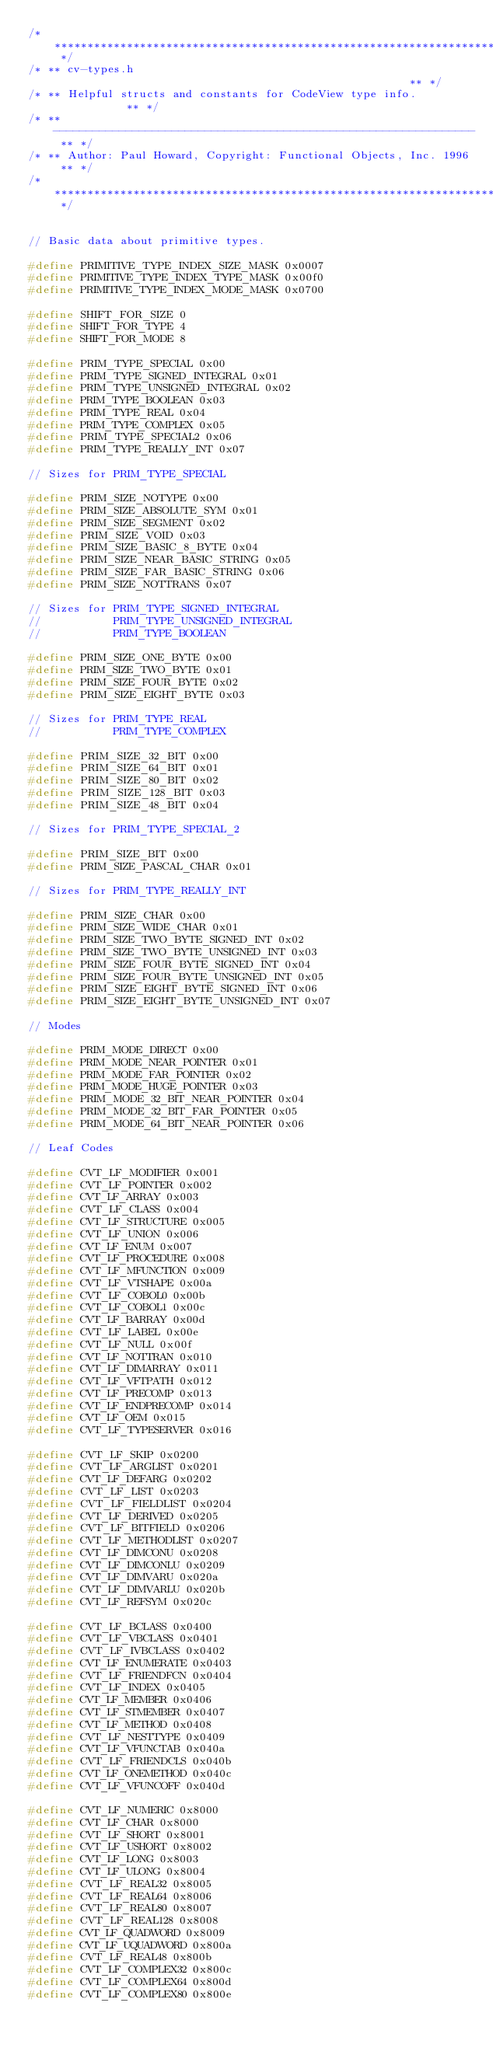Convert code to text. <code><loc_0><loc_0><loc_500><loc_500><_C_>/* ********************************************************************** */
/* ** cv-types.h                                                       ** */
/* ** Helpful structs and constants for CodeView type info.            ** */
/* ** ---------------------------------------------------------------- ** */
/* ** Author: Paul Howard, Copyright: Functional Objects, Inc. 1996 ** */
/* ********************************************************************** */


// Basic data about primitive types.

#define PRIMITIVE_TYPE_INDEX_SIZE_MASK 0x0007
#define PRIMITIVE_TYPE_INDEX_TYPE_MASK 0x00f0
#define PRIMITIVE_TYPE_INDEX_MODE_MASK 0x0700

#define SHIFT_FOR_SIZE 0
#define SHIFT_FOR_TYPE 4
#define SHIFT_FOR_MODE 8

#define PRIM_TYPE_SPECIAL 0x00
#define PRIM_TYPE_SIGNED_INTEGRAL 0x01
#define PRIM_TYPE_UNSIGNED_INTEGRAL 0x02
#define PRIM_TYPE_BOOLEAN 0x03
#define PRIM_TYPE_REAL 0x04
#define PRIM_TYPE_COMPLEX 0x05
#define PRIM_TYPE_SPECIAL2 0x06
#define PRIM_TYPE_REALLY_INT 0x07

// Sizes for PRIM_TYPE_SPECIAL

#define PRIM_SIZE_NOTYPE 0x00
#define PRIM_SIZE_ABSOLUTE_SYM 0x01
#define PRIM_SIZE_SEGMENT 0x02
#define PRIM_SIZE_VOID 0x03
#define PRIM_SIZE_BASIC_8_BYTE 0x04
#define PRIM_SIZE_NEAR_BASIC_STRING 0x05
#define PRIM_SIZE_FAR_BASIC_STRING 0x06
#define PRIM_SIZE_NOTTRANS 0x07

// Sizes for PRIM_TYPE_SIGNED_INTEGRAL
//           PRIM_TYPE_UNSIGNED_INTEGRAL
//           PRIM_TYPE_BOOLEAN

#define PRIM_SIZE_ONE_BYTE 0x00
#define PRIM_SIZE_TWO_BYTE 0x01
#define PRIM_SIZE_FOUR_BYTE 0x02
#define PRIM_SIZE_EIGHT_BYTE 0x03

// Sizes for PRIM_TYPE_REAL
//           PRIM_TYPE_COMPLEX

#define PRIM_SIZE_32_BIT 0x00
#define PRIM_SIZE_64_BIT 0x01
#define PRIM_SIZE_80_BIT 0x02
#define PRIM_SIZE_128_BIT 0x03
#define PRIM_SIZE_48_BIT 0x04

// Sizes for PRIM_TYPE_SPECIAL_2

#define PRIM_SIZE_BIT 0x00
#define PRIM_SIZE_PASCAL_CHAR 0x01

// Sizes for PRIM_TYPE_REALLY_INT

#define PRIM_SIZE_CHAR 0x00
#define PRIM_SIZE_WIDE_CHAR 0x01
#define PRIM_SIZE_TWO_BYTE_SIGNED_INT 0x02
#define PRIM_SIZE_TWO_BYTE_UNSIGNED_INT 0x03
#define PRIM_SIZE_FOUR_BYTE_SIGNED_INT 0x04
#define PRIM_SIZE_FOUR_BYTE_UNSIGNED_INT 0x05
#define PRIM_SIZE_EIGHT_BYTE_SIGNED_INT 0x06
#define PRIM_SIZE_EIGHT_BYTE_UNSIGNED_INT 0x07

// Modes

#define PRIM_MODE_DIRECT 0x00
#define PRIM_MODE_NEAR_POINTER 0x01
#define PRIM_MODE_FAR_POINTER 0x02
#define PRIM_MODE_HUGE_POINTER 0x03
#define PRIM_MODE_32_BIT_NEAR_POINTER 0x04
#define PRIM_MODE_32_BIT_FAR_POINTER 0x05
#define PRIM_MODE_64_BIT_NEAR_POINTER 0x06

// Leaf Codes

#define CVT_LF_MODIFIER 0x001
#define CVT_LF_POINTER 0x002
#define CVT_LF_ARRAY 0x003
#define CVT_LF_CLASS 0x004
#define CVT_LF_STRUCTURE 0x005
#define CVT_LF_UNION 0x006
#define CVT_LF_ENUM 0x007
#define CVT_LF_PROCEDURE 0x008
#define CVT_LF_MFUNCTION 0x009
#define CVT_LF_VTSHAPE 0x00a
#define CVT_LF_COBOL0 0x00b
#define CVT_LF_COBOL1 0x00c
#define CVT_LF_BARRAY 0x00d
#define CVT_LF_LABEL 0x00e
#define CVT_LF_NULL 0x00f
#define CVT_LF_NOTTRAN 0x010
#define CVT_LF_DIMARRAY 0x011
#define CVT_LF_VFTPATH 0x012
#define CVT_LF_PRECOMP 0x013
#define CVT_LF_ENDPRECOMP 0x014
#define CVT_LF_OEM 0x015
#define CVT_LF_TYPESERVER 0x016

#define CVT_LF_SKIP 0x0200
#define CVT_LF_ARGLIST 0x0201
#define CVT_LF_DEFARG 0x0202
#define CVT_LF_LIST 0x0203
#define CVT_LF_FIELDLIST 0x0204
#define CVT_LF_DERIVED 0x0205
#define CVT_LF_BITFIELD 0x0206
#define CVT_LF_METHODLIST 0x0207
#define CVT_LF_DIMCONU 0x0208
#define CVT_LF_DIMCONLU 0x0209
#define CVT_LF_DIMVARU 0x020a
#define CVT_LF_DIMVARLU 0x020b
#define CVT_LF_REFSYM 0x020c

#define CVT_LF_BCLASS 0x0400
#define CVT_LF_VBCLASS 0x0401
#define CVT_LF_IVBCLASS 0x0402
#define CVT_LF_ENUMERATE 0x0403
#define CVT_LF_FRIENDFCN 0x0404
#define CVT_LF_INDEX 0x0405
#define CVT_LF_MEMBER 0x0406
#define CVT_LF_STMEMBER 0x0407
#define CVT_LF_METHOD 0x0408
#define CVT_LF_NESTTYPE 0x0409
#define CVT_LF_VFUNCTAB 0x040a
#define CVT_LF_FRIENDCLS 0x040b
#define CVT_LF_ONEMETHOD 0x040c
#define CVT_LF_VFUNCOFF 0x040d

#define CVT_LF_NUMERIC 0x8000
#define CVT_LF_CHAR 0x8000
#define CVT_LF_SHORT 0x8001
#define CVT_LF_USHORT 0x8002
#define CVT_LF_LONG 0x8003
#define CVT_LF_ULONG 0x8004
#define CVT_LF_REAL32 0x8005
#define CVT_LF_REAL64 0x8006
#define CVT_LF_REAL80 0x8007
#define CVT_LF_REAL128 0x8008
#define CVT_LF_QUADWORD 0x8009
#define CVT_LF_UQUADWORD 0x800a
#define CVT_LF_REAL48 0x800b
#define CVT_LF_COMPLEX32 0x800c
#define CVT_LF_COMPLEX64 0x800d
#define CVT_LF_COMPLEX80 0x800e</code> 